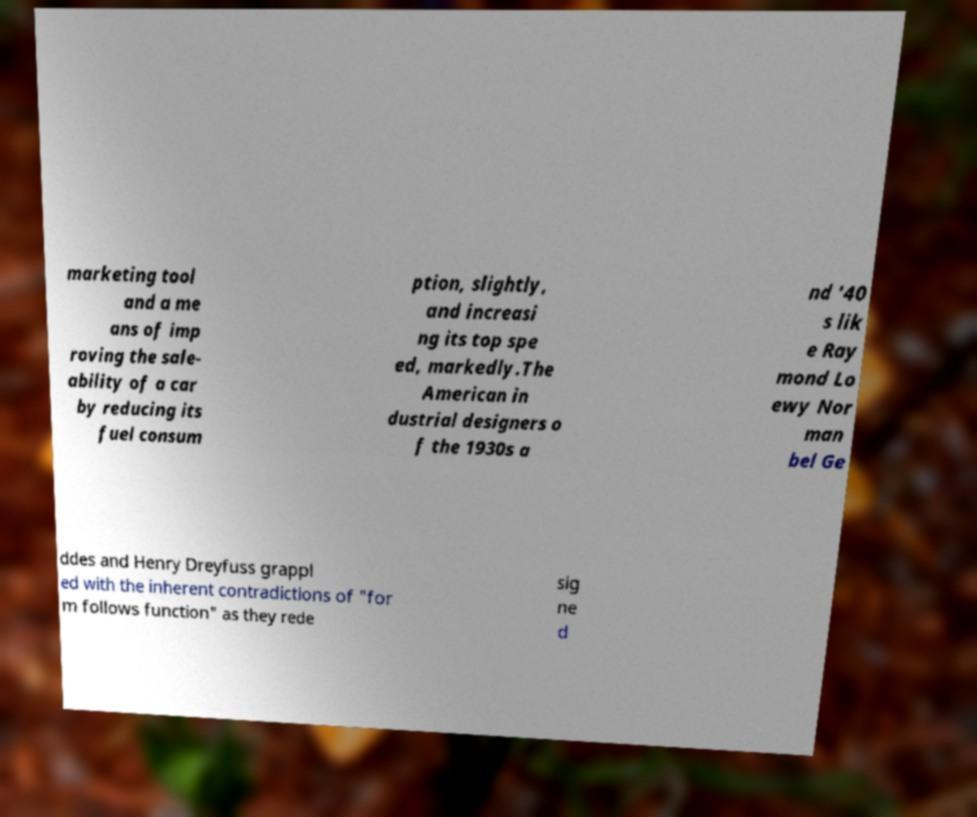Please read and relay the text visible in this image. What does it say? marketing tool and a me ans of imp roving the sale- ability of a car by reducing its fuel consum ption, slightly, and increasi ng its top spe ed, markedly.The American in dustrial designers o f the 1930s a nd '40 s lik e Ray mond Lo ewy Nor man bel Ge ddes and Henry Dreyfuss grappl ed with the inherent contradictions of "for m follows function" as they rede sig ne d 